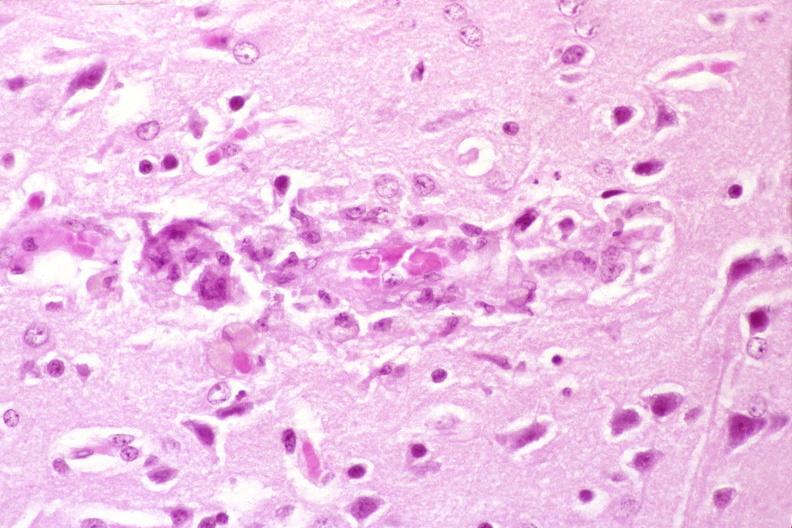does this image show brain, hiv neuropathy, microglial nodule with giant cell?
Answer the question using a single word or phrase. Yes 